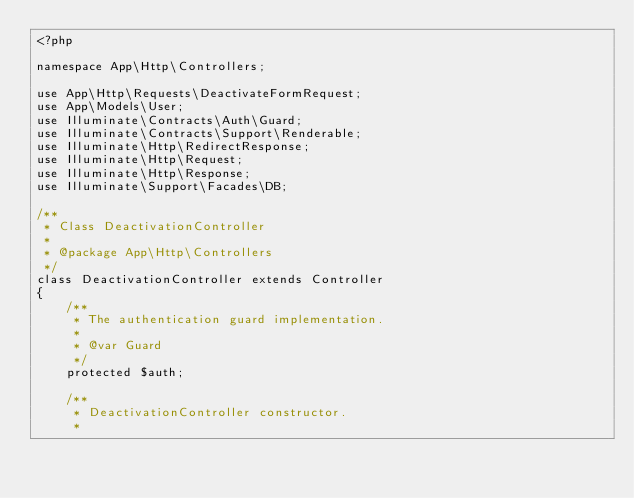<code> <loc_0><loc_0><loc_500><loc_500><_PHP_><?php

namespace App\Http\Controllers;

use App\Http\Requests\DeactivateFormRequest;
use App\Models\User;
use Illuminate\Contracts\Auth\Guard;
use Illuminate\Contracts\Support\Renderable;
use Illuminate\Http\RedirectResponse;
use Illuminate\Http\Request;
use Illuminate\Http\Response;
use Illuminate\Support\Facades\DB;

/**
 * Class DeactivationController
 *
 * @package App\Http\Controllers
 */
class DeactivationController extends Controller
{
    /**
     * The authentication guard implementation.
     *
     * @var Guard
     */
    protected $auth;

    /**
     * DeactivationController constructor.
     *</code> 